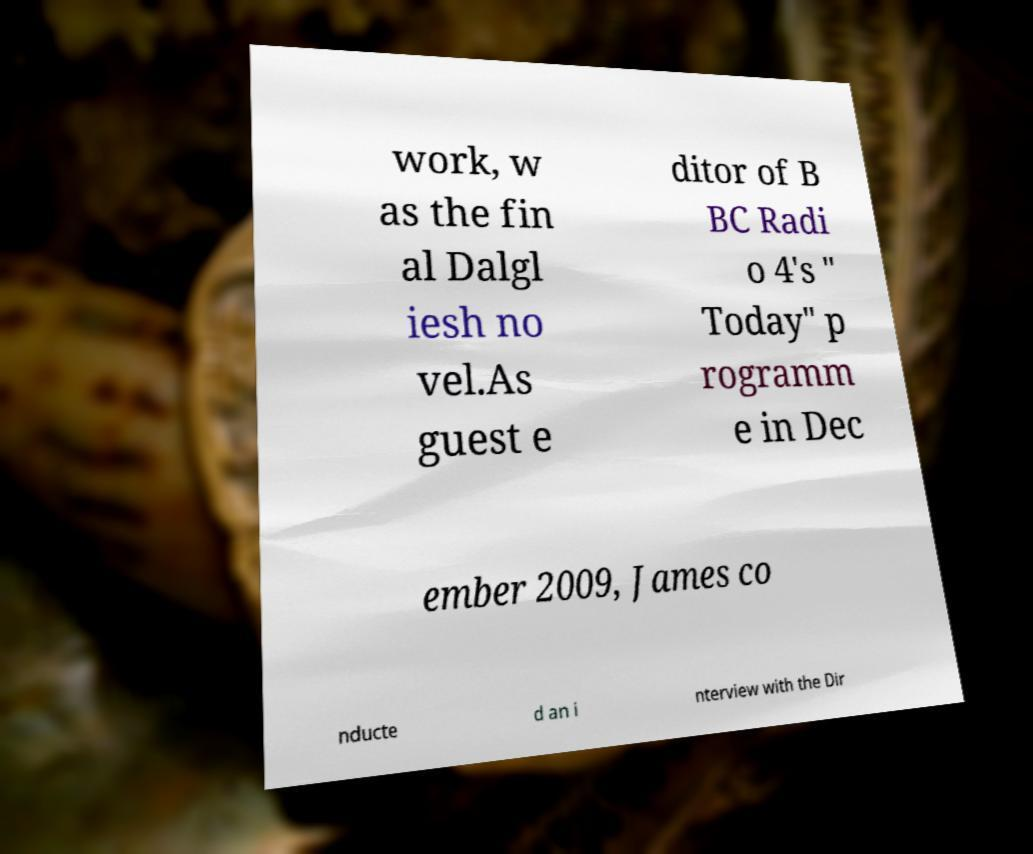Can you read and provide the text displayed in the image?This photo seems to have some interesting text. Can you extract and type it out for me? work, w as the fin al Dalgl iesh no vel.As guest e ditor of B BC Radi o 4's " Today" p rogramm e in Dec ember 2009, James co nducte d an i nterview with the Dir 